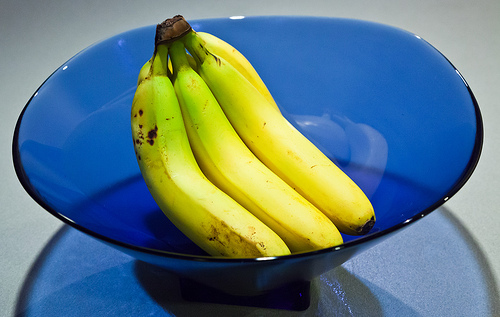<image>
Is there a bowl under the banana? Yes. The bowl is positioned underneath the banana, with the banana above it in the vertical space. Is the table in front of the bananas? No. The table is not in front of the bananas. The spatial positioning shows a different relationship between these objects. 